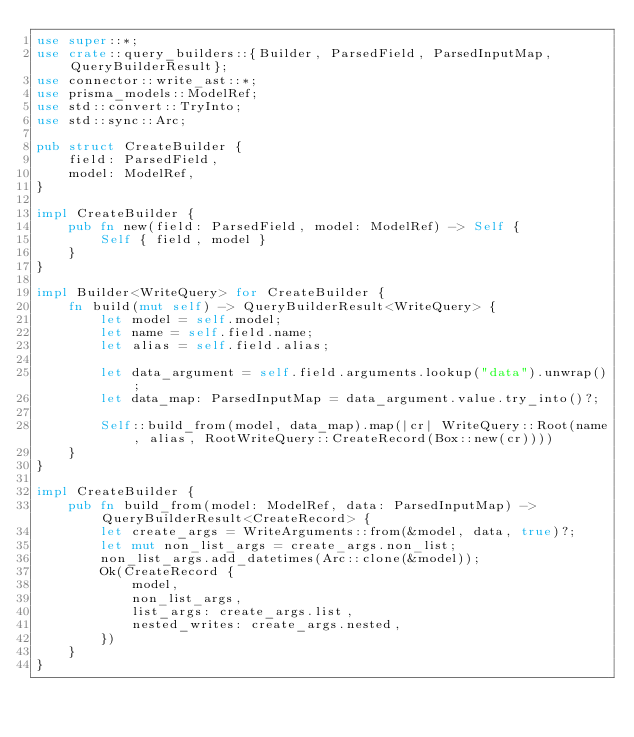<code> <loc_0><loc_0><loc_500><loc_500><_Rust_>use super::*;
use crate::query_builders::{Builder, ParsedField, ParsedInputMap, QueryBuilderResult};
use connector::write_ast::*;
use prisma_models::ModelRef;
use std::convert::TryInto;
use std::sync::Arc;

pub struct CreateBuilder {
    field: ParsedField,
    model: ModelRef,
}

impl CreateBuilder {
    pub fn new(field: ParsedField, model: ModelRef) -> Self {
        Self { field, model }
    }
}

impl Builder<WriteQuery> for CreateBuilder {
    fn build(mut self) -> QueryBuilderResult<WriteQuery> {
        let model = self.model;
        let name = self.field.name;
        let alias = self.field.alias;

        let data_argument = self.field.arguments.lookup("data").unwrap();
        let data_map: ParsedInputMap = data_argument.value.try_into()?;

        Self::build_from(model, data_map).map(|cr| WriteQuery::Root(name, alias, RootWriteQuery::CreateRecord(Box::new(cr))))
    }
}

impl CreateBuilder {
    pub fn build_from(model: ModelRef, data: ParsedInputMap) -> QueryBuilderResult<CreateRecord> {
        let create_args = WriteArguments::from(&model, data, true)?;
        let mut non_list_args = create_args.non_list;
        non_list_args.add_datetimes(Arc::clone(&model));
        Ok(CreateRecord {
            model,
            non_list_args,
            list_args: create_args.list,
            nested_writes: create_args.nested,
        })
    }
}
</code> 